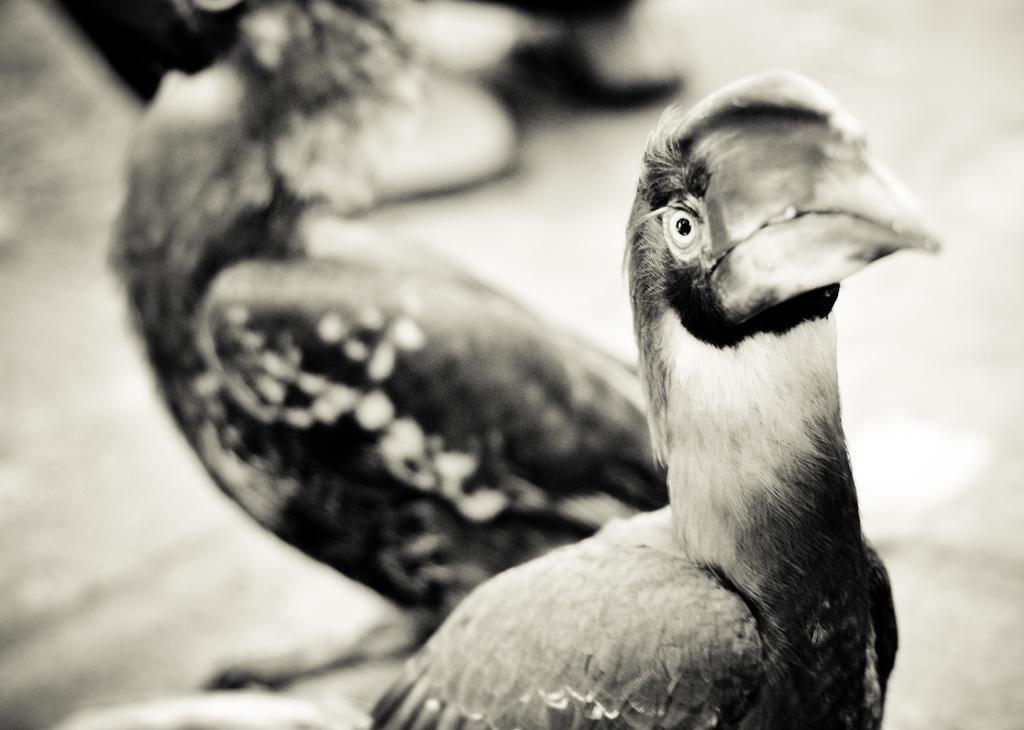Please provide a concise description of this image. In this image we can see birds. This is a black and white image. 